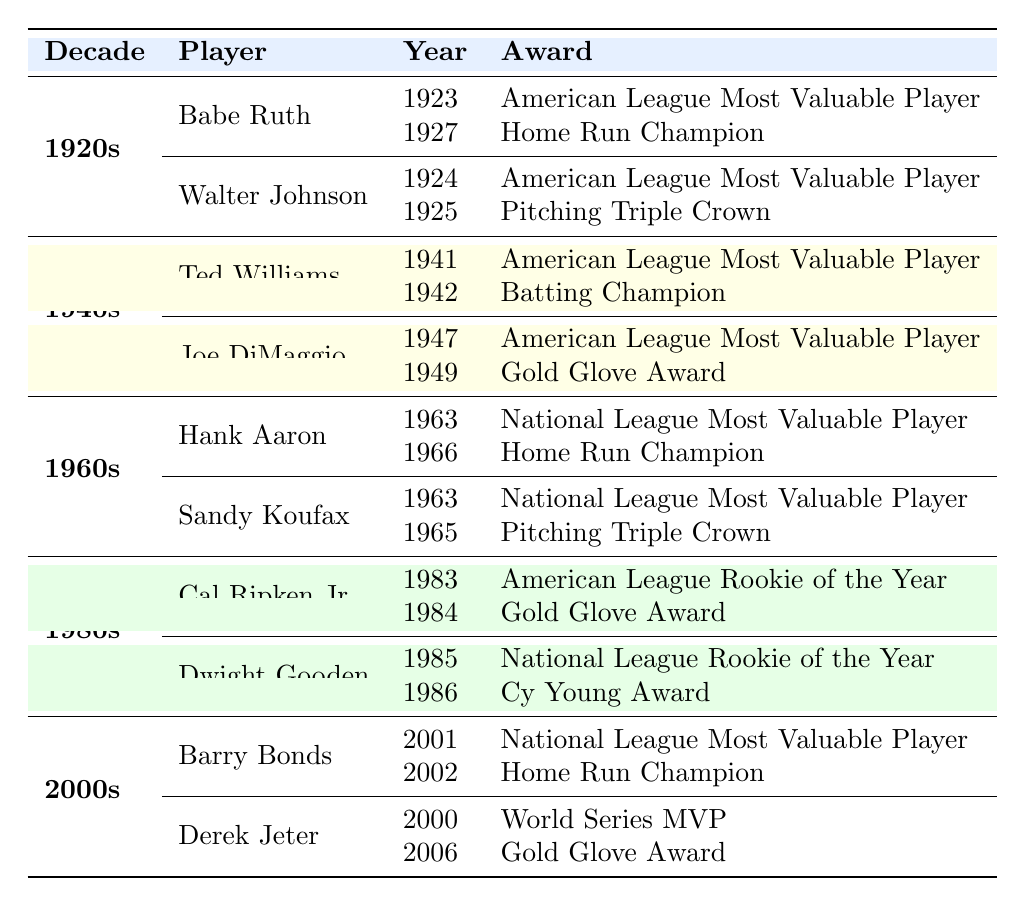What award did Babe Ruth win in 1923? The table shows that Babe Ruth received the "American League Most Valuable Player" award in 1923, which is listed under his awards section for the 1920s decade.
Answer: American League Most Valuable Player How many awards did Ted Williams receive in the 1940s? By looking at the table, Ted Williams is listed with two awards in the 1940s: "American League Most Valuable Player" in 1941 and "Batting Champion" in 1942. Therefore, he received a total of two awards during that decade.
Answer: 2 Did Joe DiMaggio receive any awards in the 1960s? The table indicates Joe DiMaggio is not listed in the 1960s section, so he did not receive any awards during that decade.
Answer: No What is the total number of awards received by players in the 1920s? Looking at the table, Babe Ruth received 2 awards and Walter Johnson received 2 awards, making a total of 4 awards for the decade.
Answer: 4 Which player received the "Gold Glove Award" twice? The table shows that Joe DiMaggio received the "Gold Glove Award" in 1949 and Derek Jeter received a "Gold Glove Award" in 2006; however, neither player received it twice within the table. The answer is no player received that award twice according to the data presented.
Answer: No player received it twice In which decade did Barry Bonds win the "Home Run Champion" award, and what year was it? The table specifies that Barry Bonds won the "Home Run Champion" award in 2002, which falls within the 2000s decade.
Answer: 2000s, 2002 Who won the "National League Rookie of the Year" award in the 1980s? According to the table, Dwight Gooden won the "National League Rookie of the Year" award in 1985 during the 1980s decade.
Answer: Dwight Gooden What is the difference in the number of awards received by the top-award player from the 1920s versus the 2000s? Babe Ruth and Walter Johnson each received 2 awards in the 1920s, while Barry Bonds received 2 awards and Derek Jeter also received 2 awards in the 2000s. Therefore, the difference is 0 awards since both decades had players with equal awards.
Answer: 0 How many players received the "American League Most Valuable Player" award across all decades? By examining the table, Babe Ruth (1923), Ted Williams (1941), Joe DiMaggio (1947), and Barry Bonds (2001) received the "American League Most Valuable Player" award, summing up to four players earning that distinction.
Answer: 4 